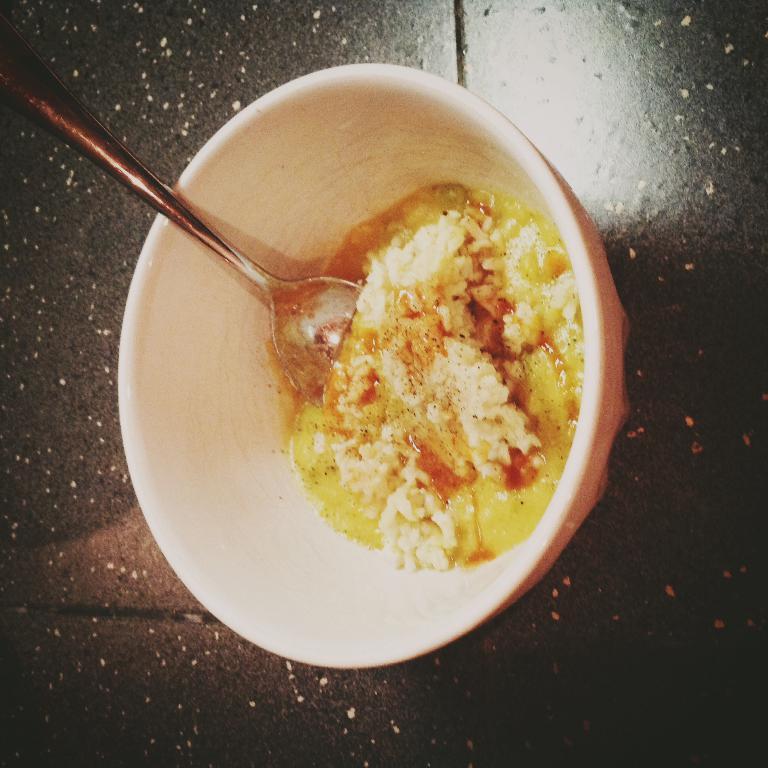How would you summarize this image in a sentence or two? In this picture there is food and spoon in the bowl. At the bottom it looks like a table. 